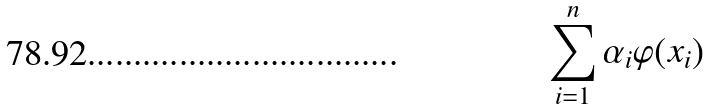Convert formula to latex. <formula><loc_0><loc_0><loc_500><loc_500>\sum _ { i = 1 } ^ { n } \alpha _ { i } \varphi ( x _ { i } )</formula> 